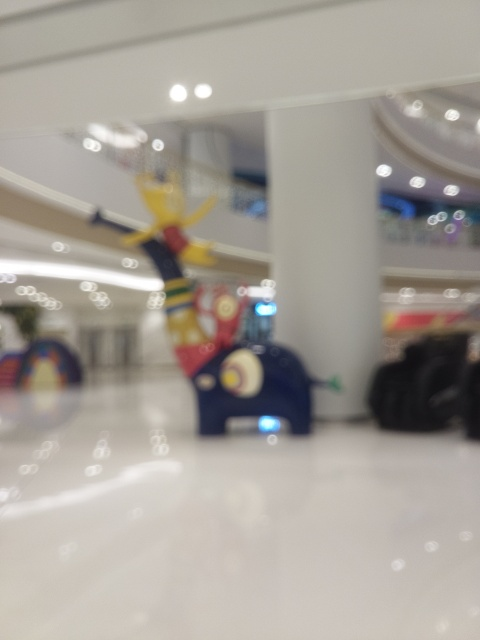What is the overall clarity of the image like?
A. Moderate
B. Very high
C. Average
D. Very low The clarity of the image is quite low, making it difficult to discern specific details. The out-of-focus nature of the photo suggests that the camera may have been shaken during the shot or the autofocus failed to find a subject to lock onto. It's possible that it was an intentional artistic choice, but from a technical standpoint, the sharpness and detail are significantly lacking. 